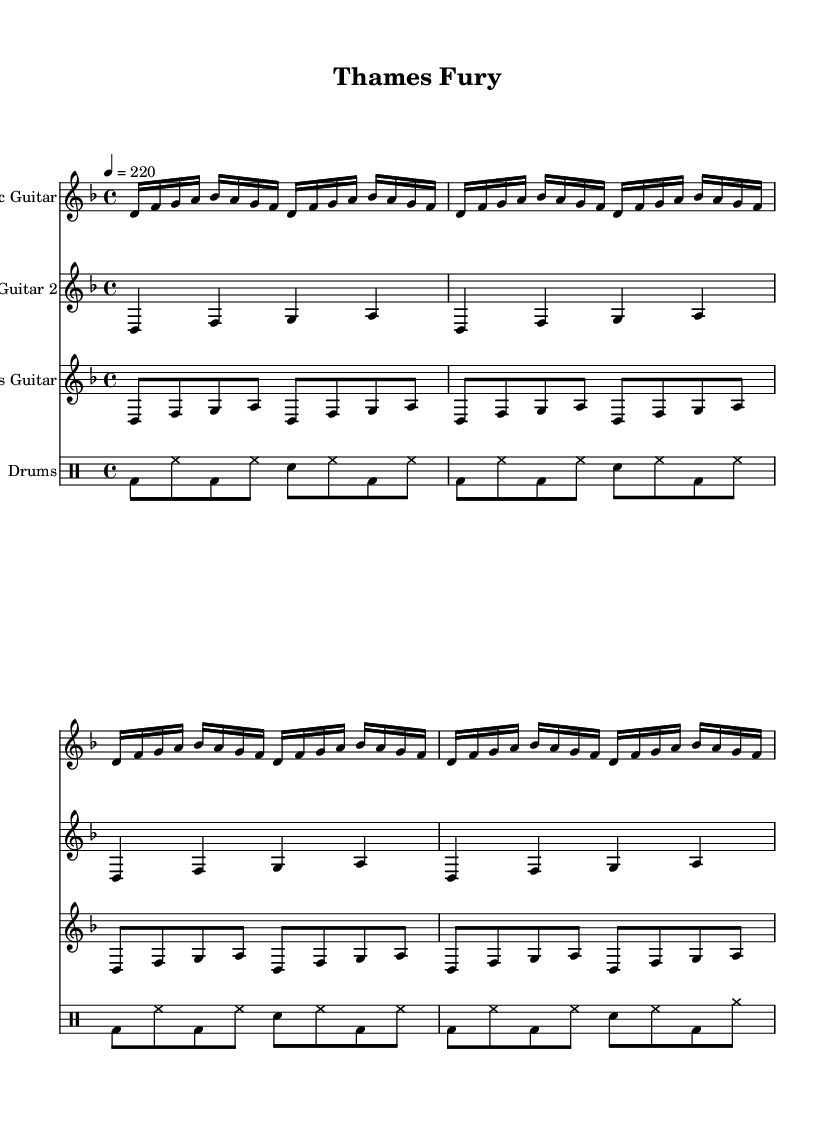What is the time signature of this music? The time signature is indicated at the beginning of the staff. In this case, it shows 4/4, meaning there are four beats in each measure and the quarter note gets one beat.
Answer: 4/4 What is the tempo marking for this piece? The tempo marking is found above the staff in beats per minute. Here, it is marked as 4 = 220, indicating the piece should be played at 220 beats per minute.
Answer: 220 What is the key signature of this music? The key signature is indicated at the beginning of the staff. It has two flats, which means the key is D minor.
Answer: D minor How many electric guitar parts are there in this music? There are two separate staffs labeled "Electric Guitar" and "Electric Guitar 2," which indicates that there are two electric guitar parts in the music.
Answer: 2 Which instrument plays the drum part? The drum part is specified in the score with a separate staff labeled "Drums," indicating that the drums are the instrument playing this part.
Answer: Drums What rhythmic pattern is prominent in the bass guitar part? The bass guitar consists of repeated eighth notes, following a steady rhythm throughout all measures of the music.
Answer: Eighth notes How does the tempo marking reflect the intensity typical in extreme metal? The tempo of 220 beats per minute is quite fast and aggressive, which aligns with the high energy and intensity often found in extreme metal genres.
Answer: Fast and aggressive 